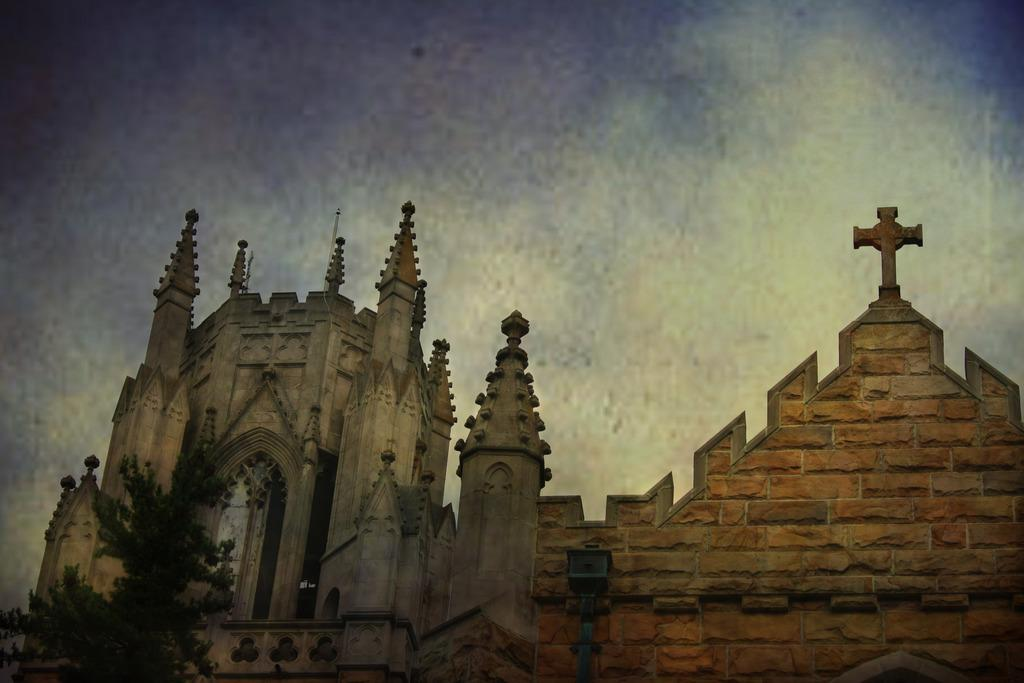What type of structures can be seen in the image? There are buildings in the image. What type of vegetation is present in the image? There is a tree in the image. What can be seen in the background of the image? The sky is visible in the background of the image. How many feet are visible on the structure in the image? There is no structure with feet present in the image; the buildings and tree do not have feet. 